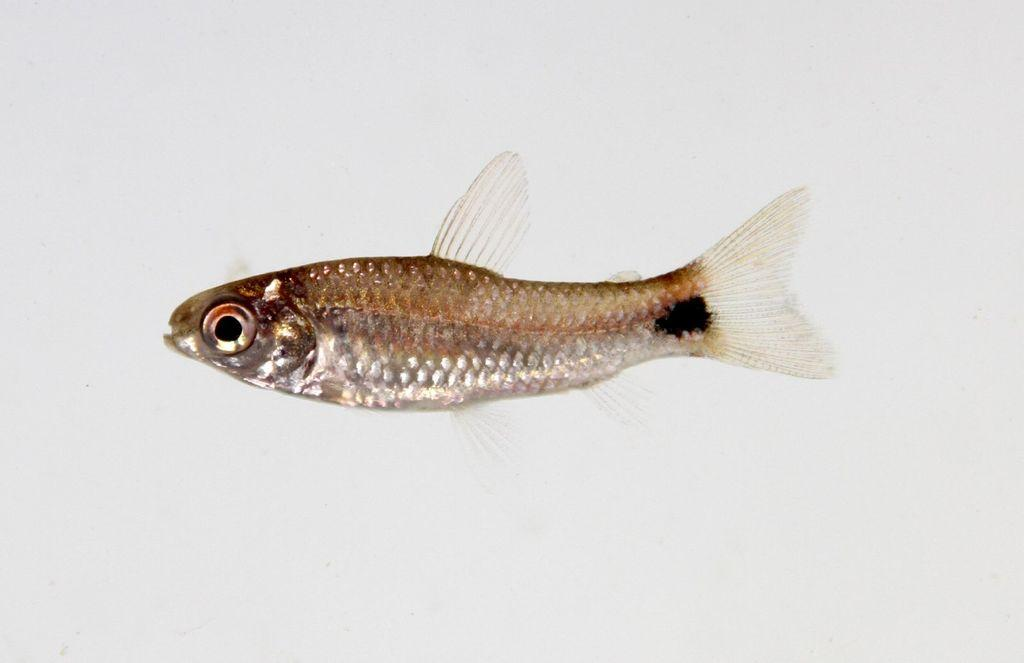What type of animal is present in the image? There is a small fish in the image. What color is the background of the image? The background of the image appears to be white in color. Where is the shoe located in the image? There is no shoe present in the image. What type of park can be seen in the background of the image? There is no park visible in the image; the background is white. 